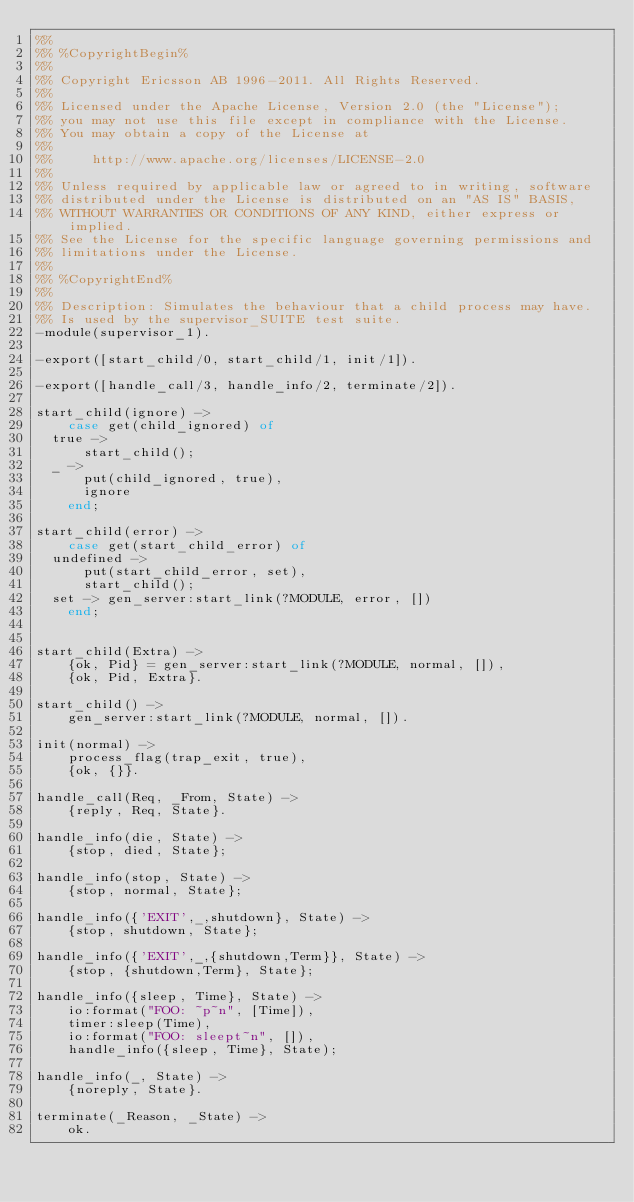Convert code to text. <code><loc_0><loc_0><loc_500><loc_500><_Erlang_>%%
%% %CopyrightBegin%
%% 
%% Copyright Ericsson AB 1996-2011. All Rights Reserved.
%% 
%% Licensed under the Apache License, Version 2.0 (the "License");
%% you may not use this file except in compliance with the License.
%% You may obtain a copy of the License at
%%
%%     http://www.apache.org/licenses/LICENSE-2.0
%%
%% Unless required by applicable law or agreed to in writing, software
%% distributed under the License is distributed on an "AS IS" BASIS,
%% WITHOUT WARRANTIES OR CONDITIONS OF ANY KIND, either express or implied.
%% See the License for the specific language governing permissions and
%% limitations under the License.
%% 
%% %CopyrightEnd%
%%
%% Description: Simulates the behaviour that a child process may have.
%% Is used by the supervisor_SUITE test suite.  
-module(supervisor_1).

-export([start_child/0, start_child/1, init/1]).

-export([handle_call/3, handle_info/2, terminate/2]).

start_child(ignore) ->
    case get(child_ignored) of
	true ->
	    start_child();
	_ ->
	    put(child_ignored, true),
	    ignore
    end;

start_child(error) ->
    case get(start_child_error) of
	undefined ->
	    put(start_child_error, set),
	    start_child();
	set -> gen_server:start_link(?MODULE, error, [])
    end;


start_child(Extra) ->
    {ok, Pid} = gen_server:start_link(?MODULE, normal, []),
    {ok, Pid, Extra}.

start_child() ->
    gen_server:start_link(?MODULE, normal, []).

init(normal) ->
    process_flag(trap_exit, true),
    {ok, {}}.

handle_call(Req, _From, State) ->
    {reply, Req, State}.

handle_info(die, State) ->
    {stop, died, State};

handle_info(stop, State) ->
    {stop, normal, State};

handle_info({'EXIT',_,shutdown}, State) ->
    {stop, shutdown, State};

handle_info({'EXIT',_,{shutdown,Term}}, State) ->
    {stop, {shutdown,Term}, State};

handle_info({sleep, Time}, State) ->
    io:format("FOO: ~p~n", [Time]),
    timer:sleep(Time),
    io:format("FOO: sleept~n", []),
    handle_info({sleep, Time}, State);

handle_info(_, State) ->
    {noreply, State}.

terminate(_Reason, _State) ->
    ok.




</code> 